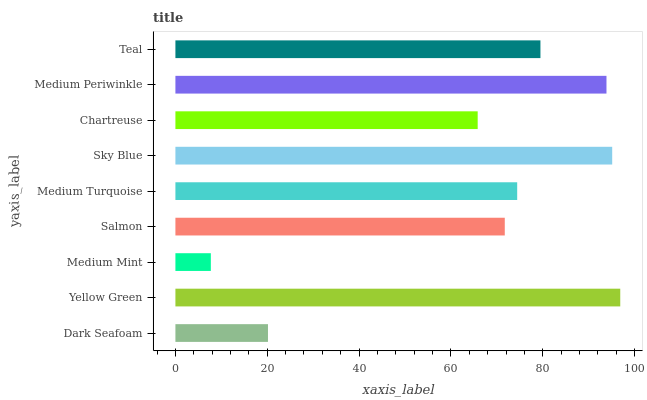Is Medium Mint the minimum?
Answer yes or no. Yes. Is Yellow Green the maximum?
Answer yes or no. Yes. Is Yellow Green the minimum?
Answer yes or no. No. Is Medium Mint the maximum?
Answer yes or no. No. Is Yellow Green greater than Medium Mint?
Answer yes or no. Yes. Is Medium Mint less than Yellow Green?
Answer yes or no. Yes. Is Medium Mint greater than Yellow Green?
Answer yes or no. No. Is Yellow Green less than Medium Mint?
Answer yes or no. No. Is Medium Turquoise the high median?
Answer yes or no. Yes. Is Medium Turquoise the low median?
Answer yes or no. Yes. Is Sky Blue the high median?
Answer yes or no. No. Is Chartreuse the low median?
Answer yes or no. No. 